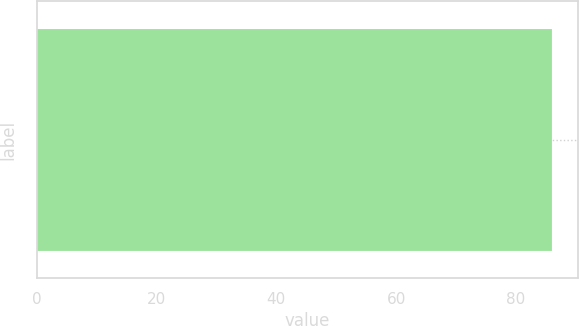Convert chart to OTSL. <chart><loc_0><loc_0><loc_500><loc_500><bar_chart><ecel><nl><fcel>86<nl></chart> 